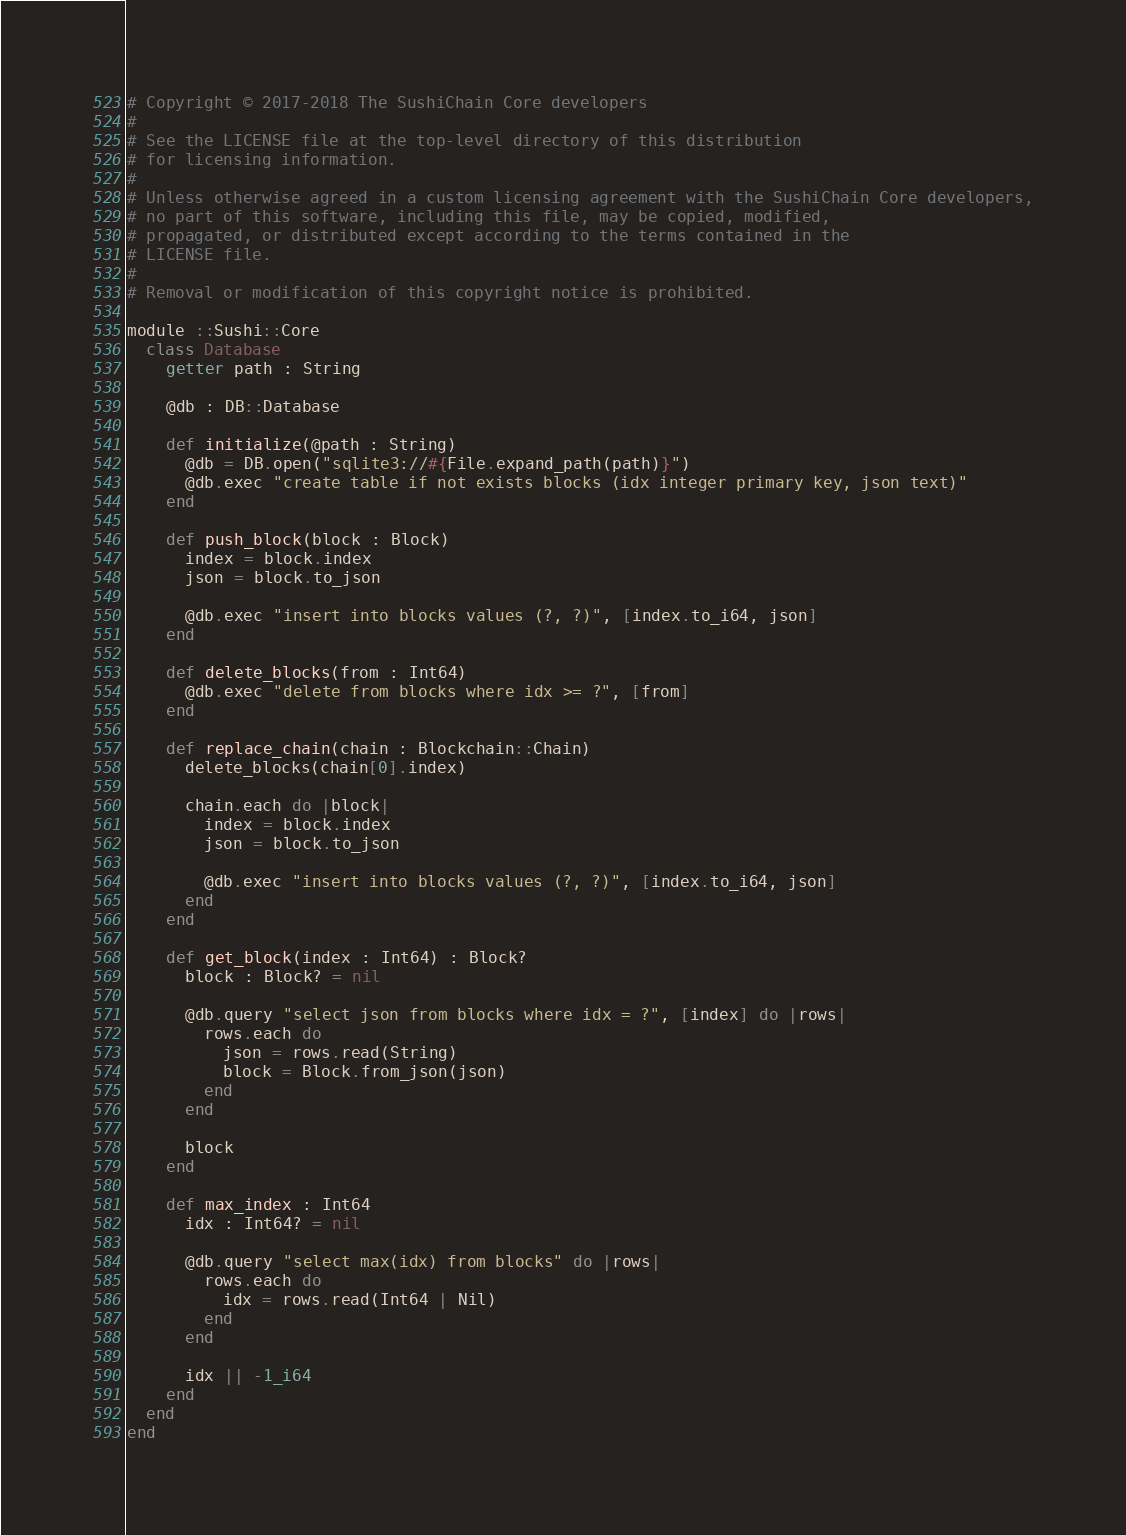<code> <loc_0><loc_0><loc_500><loc_500><_Crystal_># Copyright © 2017-2018 The SushiChain Core developers
#
# See the LICENSE file at the top-level directory of this distribution
# for licensing information.
#
# Unless otherwise agreed in a custom licensing agreement with the SushiChain Core developers,
# no part of this software, including this file, may be copied, modified,
# propagated, or distributed except according to the terms contained in the
# LICENSE file.
#
# Removal or modification of this copyright notice is prohibited.

module ::Sushi::Core
  class Database
    getter path : String

    @db : DB::Database

    def initialize(@path : String)
      @db = DB.open("sqlite3://#{File.expand_path(path)}")
      @db.exec "create table if not exists blocks (idx integer primary key, json text)"
    end

    def push_block(block : Block)
      index = block.index
      json = block.to_json

      @db.exec "insert into blocks values (?, ?)", [index.to_i64, json]
    end

    def delete_blocks(from : Int64)
      @db.exec "delete from blocks where idx >= ?", [from]
    end

    def replace_chain(chain : Blockchain::Chain)
      delete_blocks(chain[0].index)

      chain.each do |block|
        index = block.index
        json = block.to_json

        @db.exec "insert into blocks values (?, ?)", [index.to_i64, json]
      end
    end

    def get_block(index : Int64) : Block?
      block : Block? = nil

      @db.query "select json from blocks where idx = ?", [index] do |rows|
        rows.each do
          json = rows.read(String)
          block = Block.from_json(json)
        end
      end

      block
    end

    def max_index : Int64
      idx : Int64? = nil

      @db.query "select max(idx) from blocks" do |rows|
        rows.each do
          idx = rows.read(Int64 | Nil)
        end
      end

      idx || -1_i64
    end
  end
end
</code> 